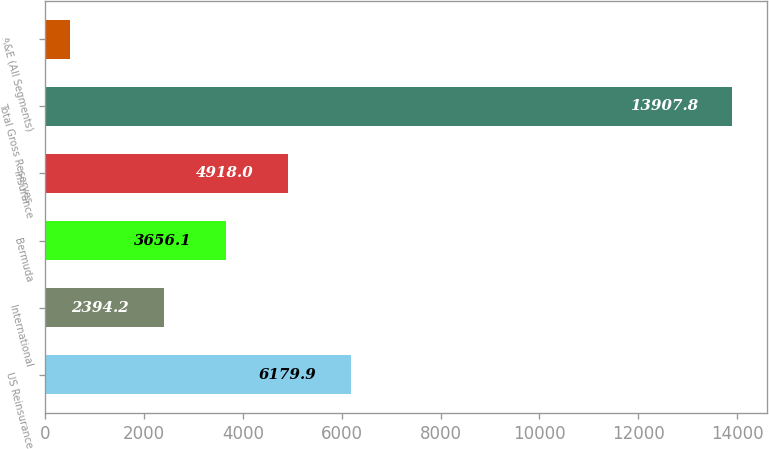Convert chart to OTSL. <chart><loc_0><loc_0><loc_500><loc_500><bar_chart><fcel>US Reinsurance<fcel>International<fcel>Bermuda<fcel>Insurance<fcel>Total Gross Reserves<fcel>A&E (All Segments)<nl><fcel>6179.9<fcel>2394.2<fcel>3656.1<fcel>4918<fcel>13907.8<fcel>510.5<nl></chart> 